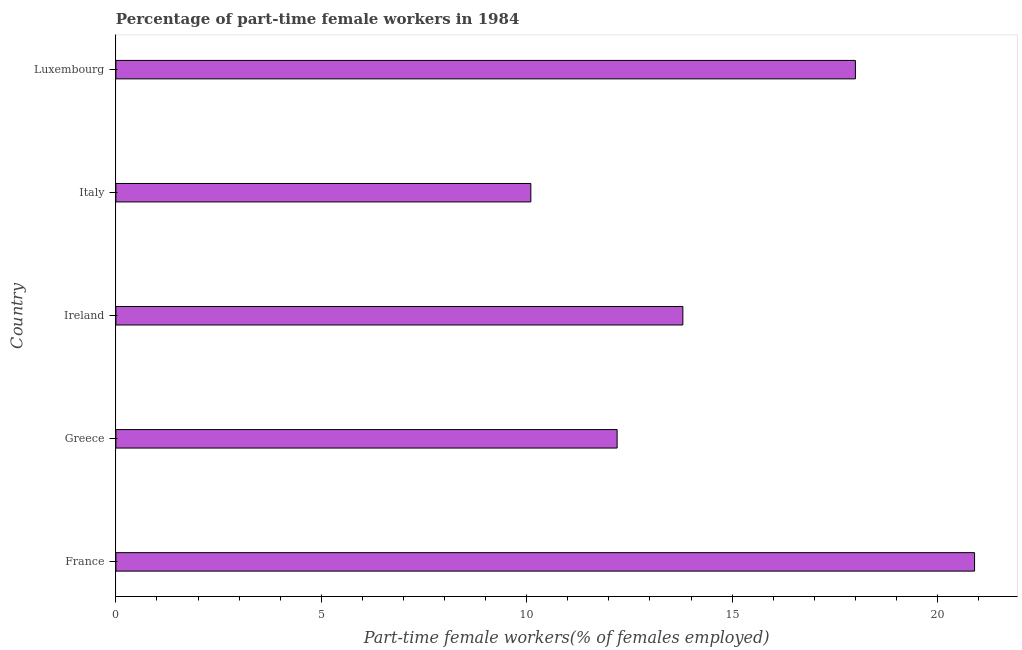Does the graph contain any zero values?
Provide a succinct answer. No. What is the title of the graph?
Your answer should be compact. Percentage of part-time female workers in 1984. What is the label or title of the X-axis?
Your answer should be compact. Part-time female workers(% of females employed). What is the label or title of the Y-axis?
Ensure brevity in your answer.  Country. What is the percentage of part-time female workers in Ireland?
Provide a short and direct response. 13.8. Across all countries, what is the maximum percentage of part-time female workers?
Your response must be concise. 20.9. Across all countries, what is the minimum percentage of part-time female workers?
Provide a succinct answer. 10.1. In which country was the percentage of part-time female workers minimum?
Keep it short and to the point. Italy. What is the sum of the percentage of part-time female workers?
Give a very brief answer. 75. What is the median percentage of part-time female workers?
Offer a very short reply. 13.8. What is the ratio of the percentage of part-time female workers in Greece to that in Italy?
Your answer should be very brief. 1.21. Is the percentage of part-time female workers in France less than that in Luxembourg?
Your answer should be very brief. No. Is the difference between the percentage of part-time female workers in France and Luxembourg greater than the difference between any two countries?
Keep it short and to the point. No. What is the difference between the highest and the second highest percentage of part-time female workers?
Your response must be concise. 2.9. What is the difference between the highest and the lowest percentage of part-time female workers?
Make the answer very short. 10.8. In how many countries, is the percentage of part-time female workers greater than the average percentage of part-time female workers taken over all countries?
Your answer should be very brief. 2. How many bars are there?
Provide a short and direct response. 5. How many countries are there in the graph?
Your answer should be very brief. 5. What is the difference between two consecutive major ticks on the X-axis?
Your response must be concise. 5. What is the Part-time female workers(% of females employed) in France?
Your answer should be compact. 20.9. What is the Part-time female workers(% of females employed) of Greece?
Offer a terse response. 12.2. What is the Part-time female workers(% of females employed) of Ireland?
Your answer should be very brief. 13.8. What is the Part-time female workers(% of females employed) in Italy?
Give a very brief answer. 10.1. What is the Part-time female workers(% of females employed) of Luxembourg?
Provide a succinct answer. 18. What is the difference between the Part-time female workers(% of females employed) in France and Ireland?
Offer a very short reply. 7.1. What is the difference between the Part-time female workers(% of females employed) in France and Luxembourg?
Keep it short and to the point. 2.9. What is the difference between the Part-time female workers(% of females employed) in Greece and Luxembourg?
Your answer should be compact. -5.8. What is the difference between the Part-time female workers(% of females employed) in Ireland and Luxembourg?
Provide a succinct answer. -4.2. What is the ratio of the Part-time female workers(% of females employed) in France to that in Greece?
Offer a terse response. 1.71. What is the ratio of the Part-time female workers(% of females employed) in France to that in Ireland?
Give a very brief answer. 1.51. What is the ratio of the Part-time female workers(% of females employed) in France to that in Italy?
Provide a succinct answer. 2.07. What is the ratio of the Part-time female workers(% of females employed) in France to that in Luxembourg?
Your answer should be very brief. 1.16. What is the ratio of the Part-time female workers(% of females employed) in Greece to that in Ireland?
Give a very brief answer. 0.88. What is the ratio of the Part-time female workers(% of females employed) in Greece to that in Italy?
Provide a succinct answer. 1.21. What is the ratio of the Part-time female workers(% of females employed) in Greece to that in Luxembourg?
Your response must be concise. 0.68. What is the ratio of the Part-time female workers(% of females employed) in Ireland to that in Italy?
Offer a very short reply. 1.37. What is the ratio of the Part-time female workers(% of females employed) in Ireland to that in Luxembourg?
Your response must be concise. 0.77. What is the ratio of the Part-time female workers(% of females employed) in Italy to that in Luxembourg?
Ensure brevity in your answer.  0.56. 